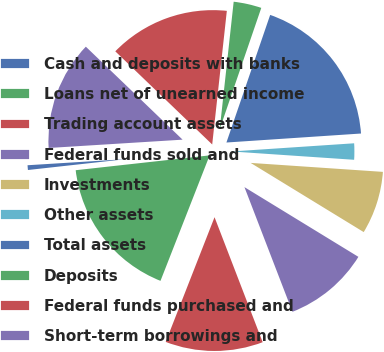<chart> <loc_0><loc_0><loc_500><loc_500><pie_chart><fcel>Cash and deposits with banks<fcel>Loans net of unearned income<fcel>Trading account assets<fcel>Federal funds sold and<fcel>Investments<fcel>Other assets<fcel>Total assets<fcel>Deposits<fcel>Federal funds purchased and<fcel>Short-term borrowings and<nl><fcel>0.77%<fcel>17.3%<fcel>11.79%<fcel>10.41%<fcel>7.66%<fcel>2.14%<fcel>18.68%<fcel>3.52%<fcel>14.55%<fcel>13.17%<nl></chart> 